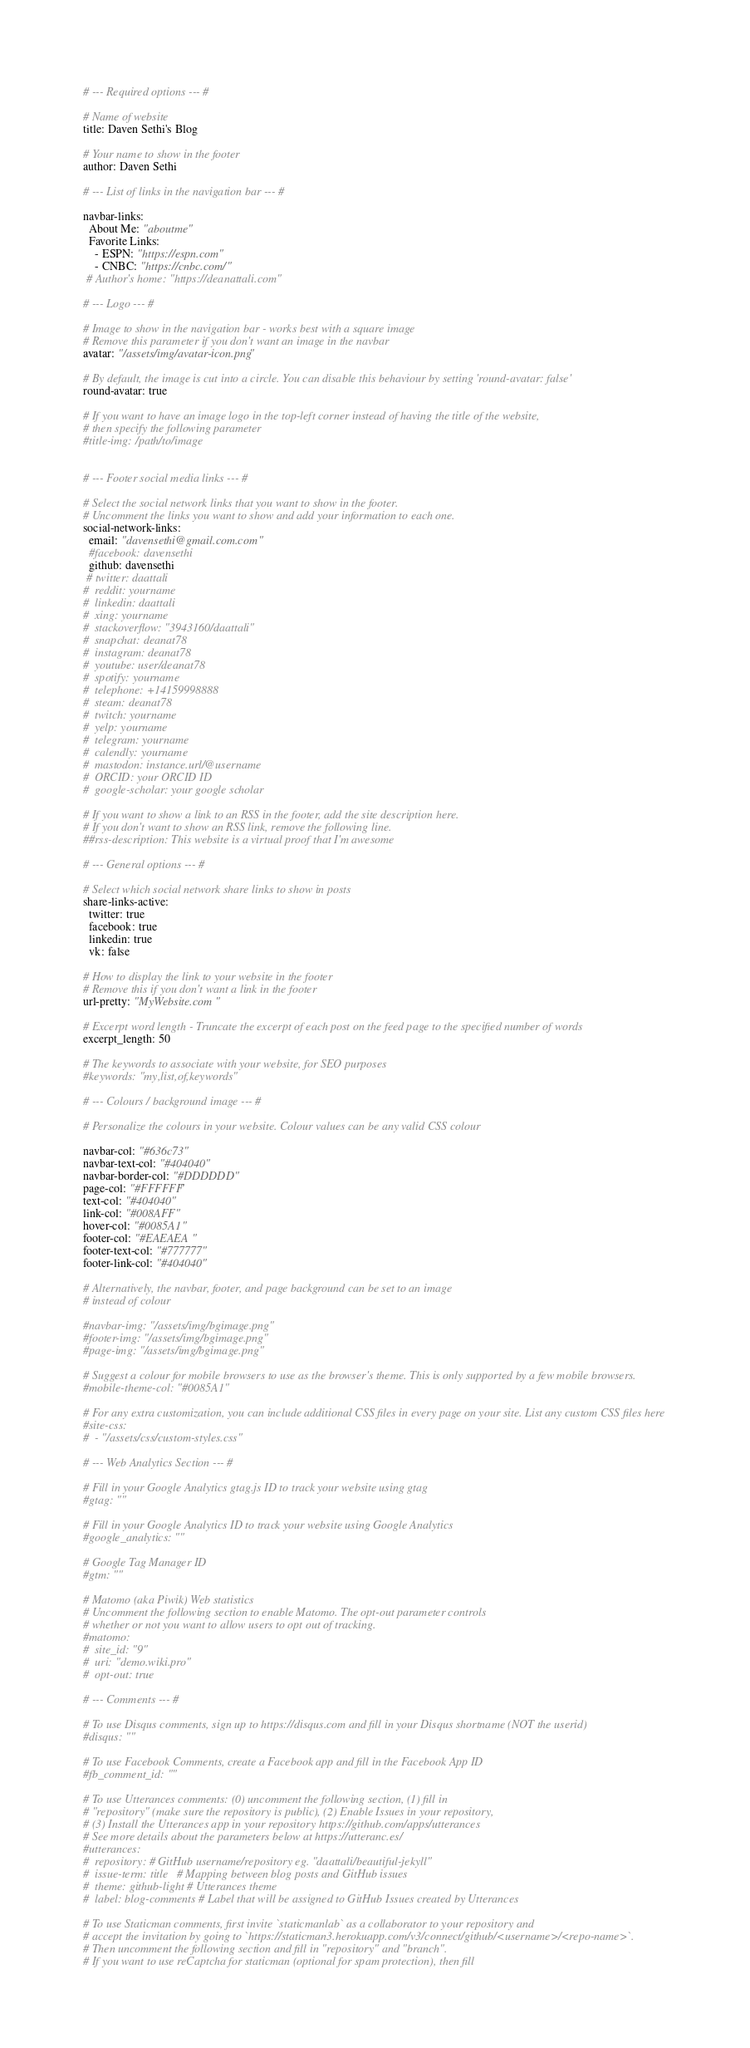Convert code to text. <code><loc_0><loc_0><loc_500><loc_500><_YAML_># --- Required options --- #

# Name of website
title: Daven Sethi's Blog

# Your name to show in the footer
author: Daven Sethi

# --- List of links in the navigation bar --- #

navbar-links:
  About Me: "aboutme"
  Favorite Links:
    - ESPN: "https://espn.com"
    - CNBC: "https://cnbc.com/"
 # Author's home: "https://deanattali.com"

# --- Logo --- #

# Image to show in the navigation bar - works best with a square image
# Remove this parameter if you don't want an image in the navbar
avatar: "/assets/img/avatar-icon.png"

# By default, the image is cut into a circle. You can disable this behaviour by setting 'round-avatar: false'
round-avatar: true

# If you want to have an image logo in the top-left corner instead of having the title of the website,
# then specify the following parameter
#title-img: /path/to/image


# --- Footer social media links --- #

# Select the social network links that you want to show in the footer.
# Uncomment the links you want to show and add your information to each one.
social-network-links:
  email: "davensethi@gmail.com.com"
  #facebook: davensethi
  github: davensethi
 # twitter: daattali
#  reddit: yourname
#  linkedin: daattali
#  xing: yourname
#  stackoverflow: "3943160/daattali"
#  snapchat: deanat78
#  instagram: deanat78
#  youtube: user/deanat78
#  spotify: yourname
#  telephone: +14159998888
#  steam: deanat78
#  twitch: yourname
#  yelp: yourname
#  telegram: yourname
#  calendly: yourname
#  mastodon: instance.url/@username
#  ORCID: your ORCID ID
#  google-scholar: your google scholar

# If you want to show a link to an RSS in the footer, add the site description here.
# If you don't want to show an RSS link, remove the following line.
##rss-description: This website is a virtual proof that I'm awesome

# --- General options --- #

# Select which social network share links to show in posts
share-links-active:
  twitter: true
  facebook: true
  linkedin: true
  vk: false

# How to display the link to your website in the footer
# Remove this if you don't want a link in the footer
url-pretty: "MyWebsite.com"

# Excerpt word length - Truncate the excerpt of each post on the feed page to the specified number of words
excerpt_length: 50

# The keywords to associate with your website, for SEO purposes
#keywords: "my,list,of,keywords"

# --- Colours / background image --- #

# Personalize the colours in your website. Colour values can be any valid CSS colour

navbar-col: "#636c73"
navbar-text-col: "#404040"
navbar-border-col: "#DDDDDD"
page-col: "#FFFFFF"
text-col: "#404040"
link-col: "#008AFF"
hover-col: "#0085A1"
footer-col: "#EAEAEA"
footer-text-col: "#777777"
footer-link-col: "#404040"

# Alternatively, the navbar, footer, and page background can be set to an image
# instead of colour

#navbar-img: "/assets/img/bgimage.png"
#footer-img: "/assets/img/bgimage.png"
#page-img: "/assets/img/bgimage.png"

# Suggest a colour for mobile browsers to use as the browser's theme. This is only supported by a few mobile browsers.
#mobile-theme-col: "#0085A1"

# For any extra customization, you can include additional CSS files in every page on your site. List any custom CSS files here
#site-css:
#  - "/assets/css/custom-styles.css"

# --- Web Analytics Section --- #

# Fill in your Google Analytics gtag.js ID to track your website using gtag
#gtag: ""

# Fill in your Google Analytics ID to track your website using Google Analytics
#google_analytics: ""

# Google Tag Manager ID
#gtm: ""

# Matomo (aka Piwik) Web statistics
# Uncomment the following section to enable Matomo. The opt-out parameter controls
# whether or not you want to allow users to opt out of tracking.
#matomo:
#  site_id: "9"
#  uri: "demo.wiki.pro"
#  opt-out: true

# --- Comments --- #

# To use Disqus comments, sign up to https://disqus.com and fill in your Disqus shortname (NOT the userid)
#disqus: ""

# To use Facebook Comments, create a Facebook app and fill in the Facebook App ID
#fb_comment_id: ""

# To use Utterances comments: (0) uncomment the following section, (1) fill in
# "repository" (make sure the repository is public), (2) Enable Issues in your repository,
# (3) Install the Utterances app in your repository https://github.com/apps/utterances
# See more details about the parameters below at https://utteranc.es/
#utterances:
#  repository: # GitHub username/repository eg. "daattali/beautiful-jekyll"
#  issue-term: title   # Mapping between blog posts and GitHub issues
#  theme: github-light # Utterances theme
#  label: blog-comments # Label that will be assigned to GitHub Issues created by Utterances

# To use Staticman comments, first invite `staticmanlab` as a collaborator to your repository and
# accept the invitation by going to `https://staticman3.herokuapp.com/v3/connect/github/<username>/<repo-name>`.
# Then uncomment the following section and fill in "repository" and "branch".
# If you want to use reCaptcha for staticman (optional for spam protection), then fill</code> 